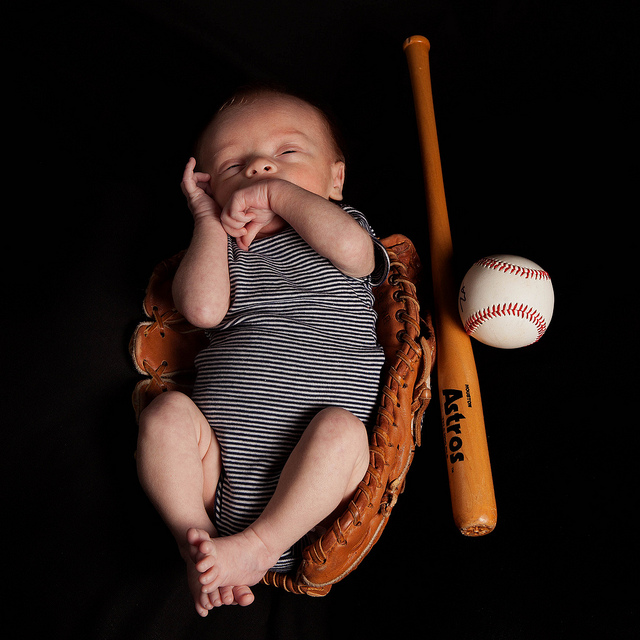Read and extract the text from this image. ASTROS 